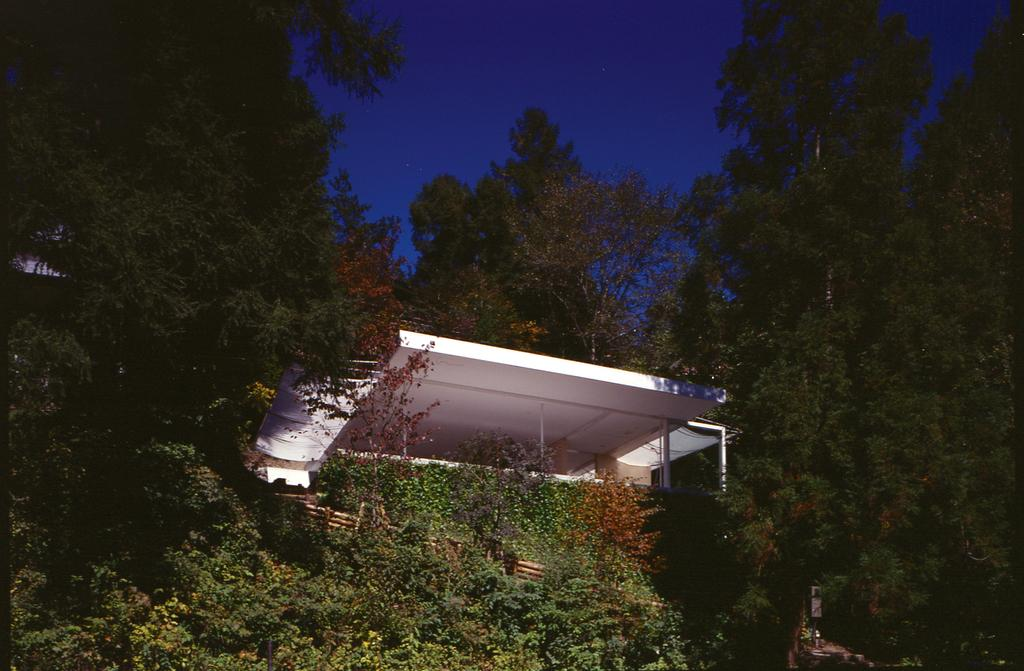What structure is present in the image? There is a shed in the image. What color is the shed? The shed is white. What can be seen in the background of the image? There are trees and the sky visible in the background of the image. What color are the trees? The trees are green. What color is the sky? The sky is blue. What happens to the shed when it bursts in the image? There is no indication in the image that the shed bursts, so this scenario cannot be observed. 